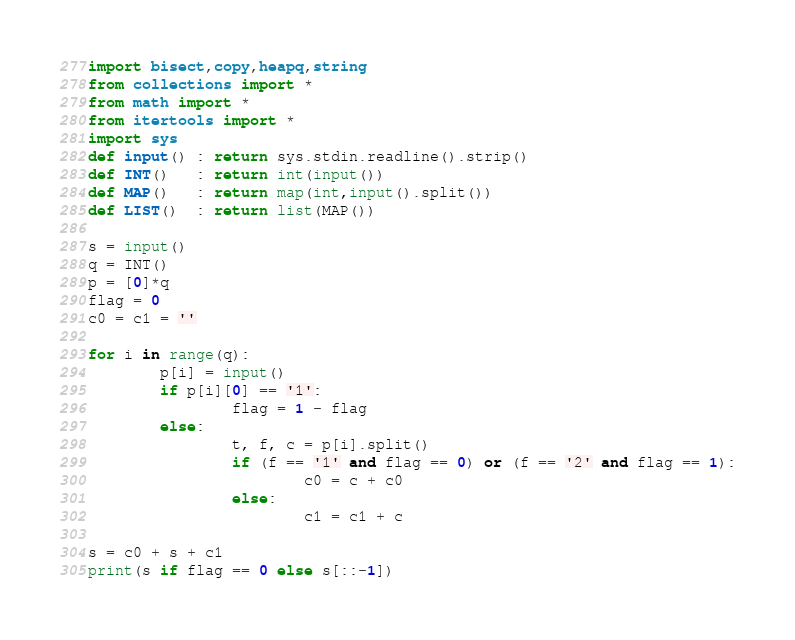<code> <loc_0><loc_0><loc_500><loc_500><_Python_>import bisect,copy,heapq,string
from collections import *
from math import *
from itertools import *
import sys
def input() : return sys.stdin.readline().strip()
def INT()   : return int(input())
def MAP()   : return map(int,input().split())
def LIST()  : return list(MAP())

s = input()
q = INT()
p = [0]*q
flag = 0
c0 = c1 = ''

for i in range(q):
        p[i] = input()
        if p[i][0] == '1':
                flag = 1 - flag
        else:
                t, f, c = p[i].split()
                if (f == '1' and flag == 0) or (f == '2' and flag == 1):
                        c0 = c + c0
                else:
                        c1 = c1 + c

s = c0 + s + c1
print(s if flag == 0 else s[::-1])</code> 